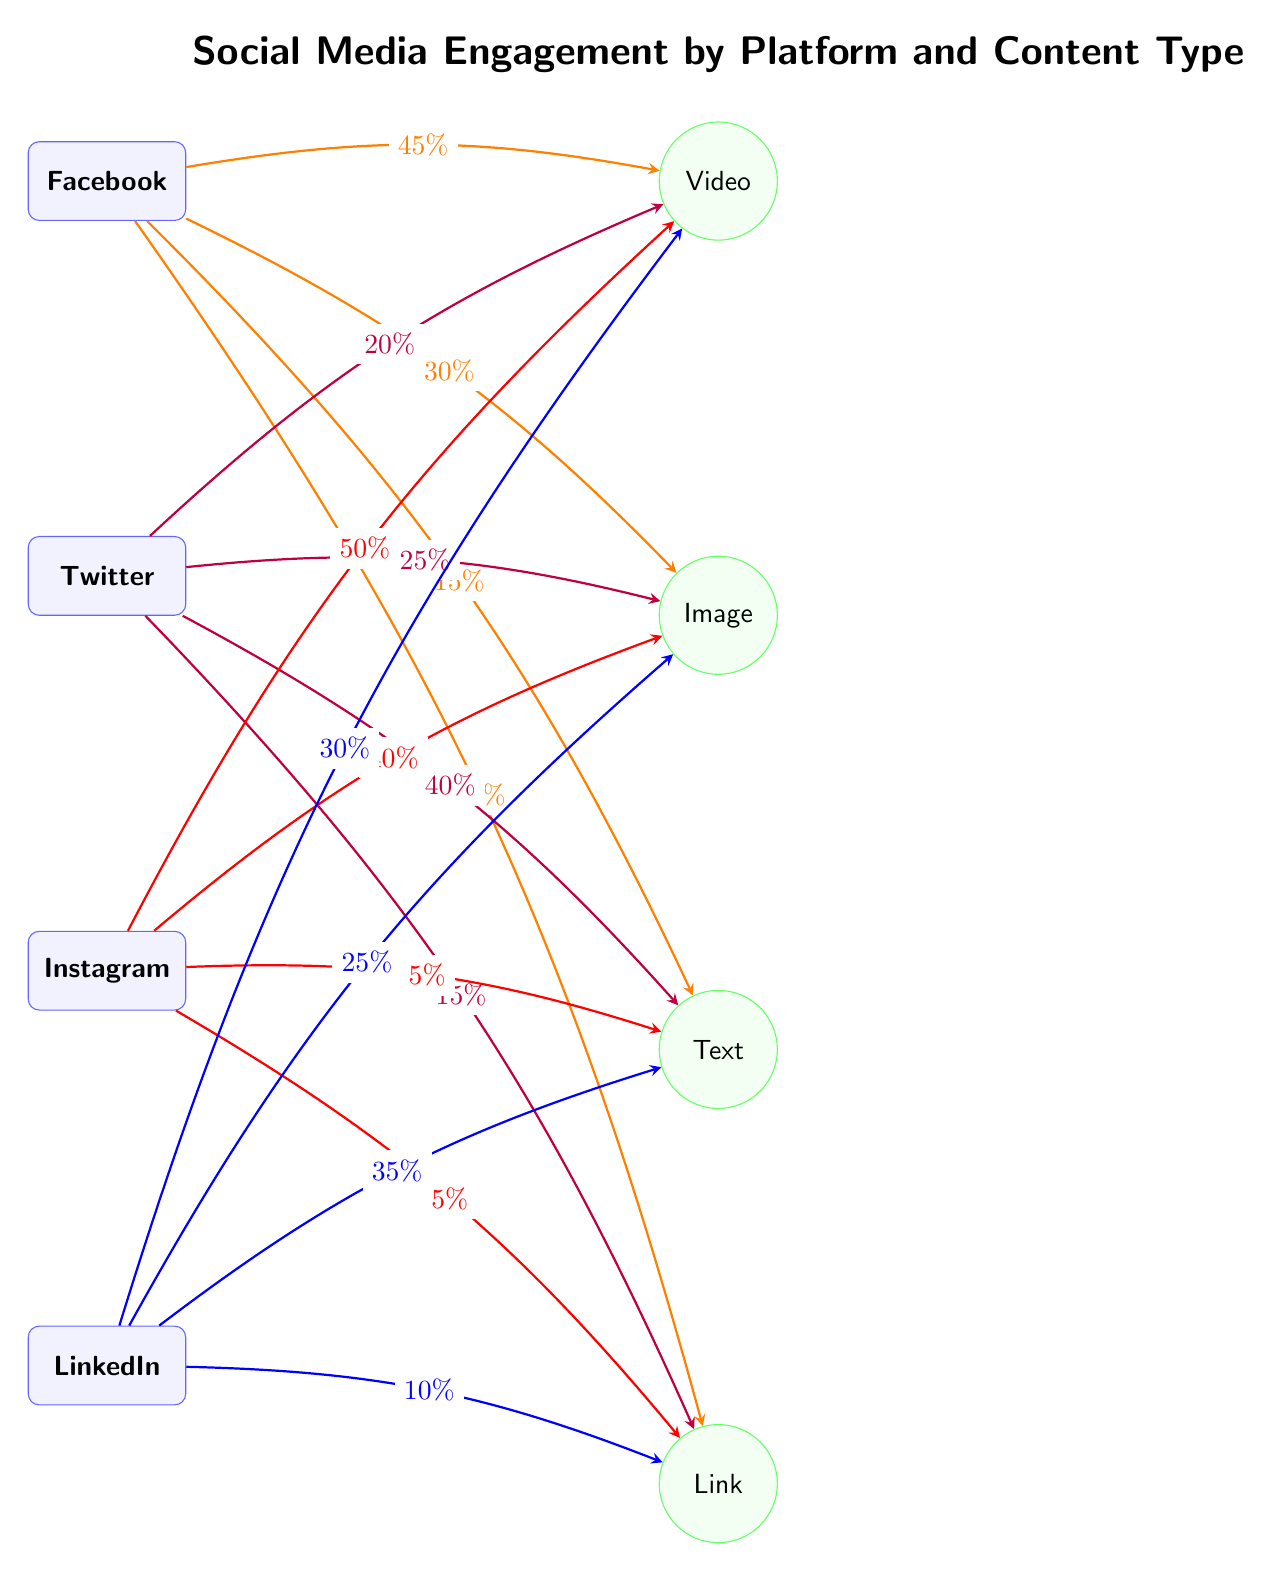What is the percentage of engagement on Facebook for Video content? From the diagram, we can see a directed arrow from the Facebook node to the Video node with the label indicating "45%". This shows that 45% of engagement on Facebook is attributed to Video content.
Answer: 45% Which platform has the highest percentage of engagement for Image content? By comparing the percentages labeled on the arrows pointing towards the Image node from each platform, we find Facebook with 30%, Twitter with 25%, Instagram with 40%, and LinkedIn with 25%. The highest percentage for Image content comes from Instagram at 40%.
Answer: Instagram What is the total number of content types represented in the diagram? The diagram contains four content types: Video, Image, Text, and Link. Counting these content types gives us a total of 4.
Answer: 4 What percentage of engagement on LinkedIn comes from Text content? Referring to the arrow from the LinkedIn node to the Text node, the percentage is labeled as "35%". This represents the engagement contribution from Text content on LinkedIn.
Answer: 35% Which platform has the least engagement for Link content? Looking at the percentages from each platform to the Link content type, Facebook has 10%, Twitter has 15%, Instagram has 5%, and LinkedIn has 10%. The lowest engagement for Link content specifically comes from Instagram at 5%.
Answer: Instagram What percentage of Twitter engagement comes from Text content compared to Video content? For Twitter, the percentage for Text content is labeled "40%" while for Video it's "20%". Therefore, the engagement from Text content (40%) is twice that of the Video content (20%) on Twitter.
Answer: 40% (Text) vs 20% (Video) What is the total engagement percentage for Video content across all platforms? Summing the percentages for Video content from each platform: Facebook (45%) + Twitter (20%) + Instagram (50%) + LinkedIn (30%) equals 145%. Thus, the total engagement percentage for Video content across all platforms is 145%.
Answer: 145% Which content type has the least engagement across all platforms? Evaluating the percentage of engagement across all platforms for each content type: Text (15%, 40%, 5%, 35%), Link (10%, 15%, 5%, 10%). The lowest is 5%, which occurs for both Instagram's Text and Link content types; however, Text has higher engagement elsewhere, placing Link as the "least engaged". Thus, Link content has the least engagement overall.
Answer: Link 